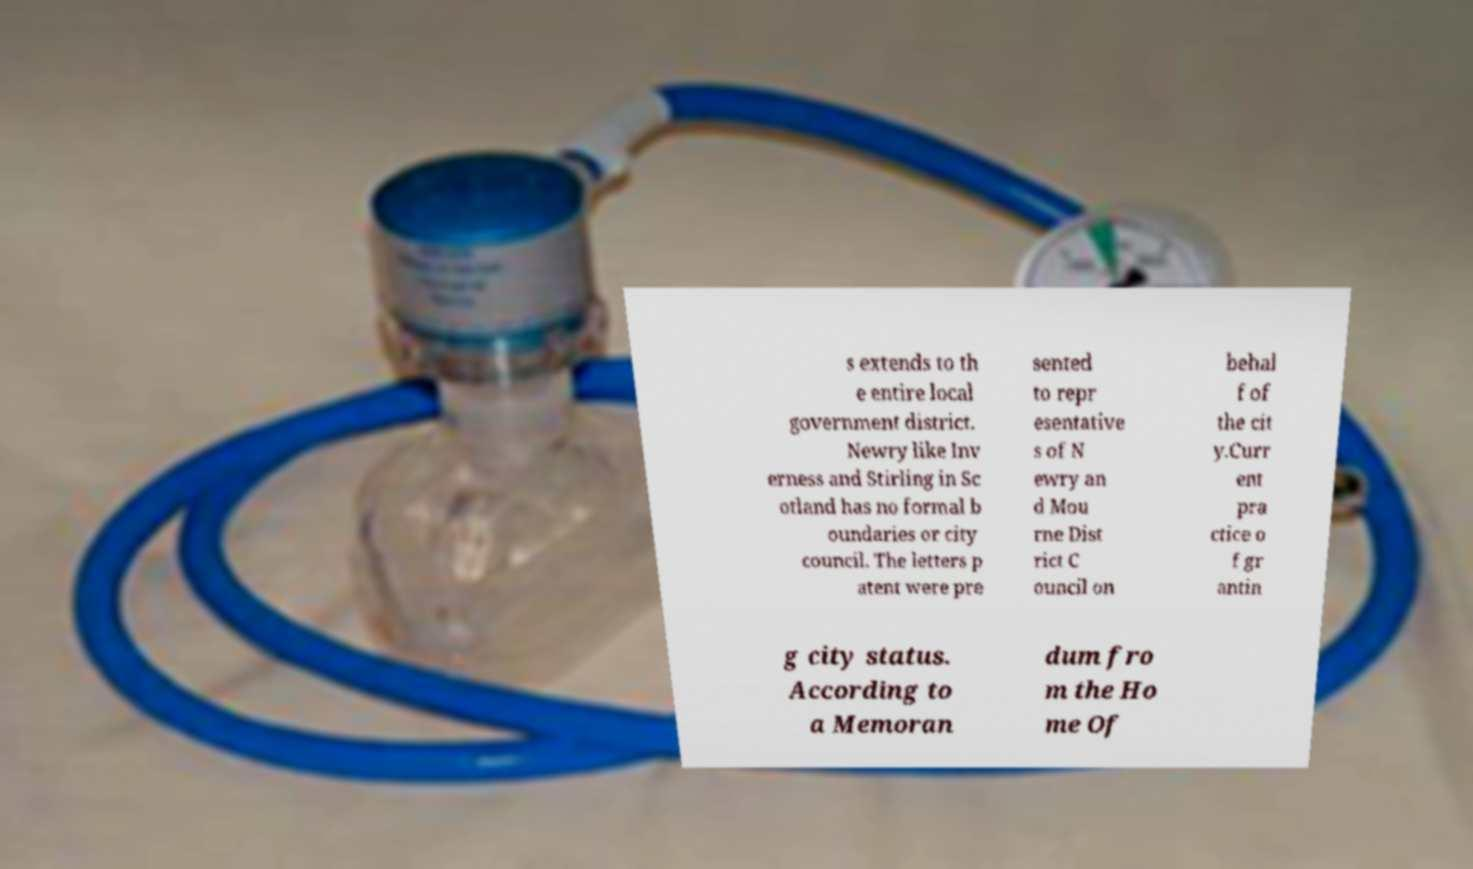Please read and relay the text visible in this image. What does it say? s extends to th e entire local government district. Newry like Inv erness and Stirling in Sc otland has no formal b oundaries or city council. The letters p atent were pre sented to repr esentative s of N ewry an d Mou rne Dist rict C ouncil on behal f of the cit y.Curr ent pra ctice o f gr antin g city status. According to a Memoran dum fro m the Ho me Of 